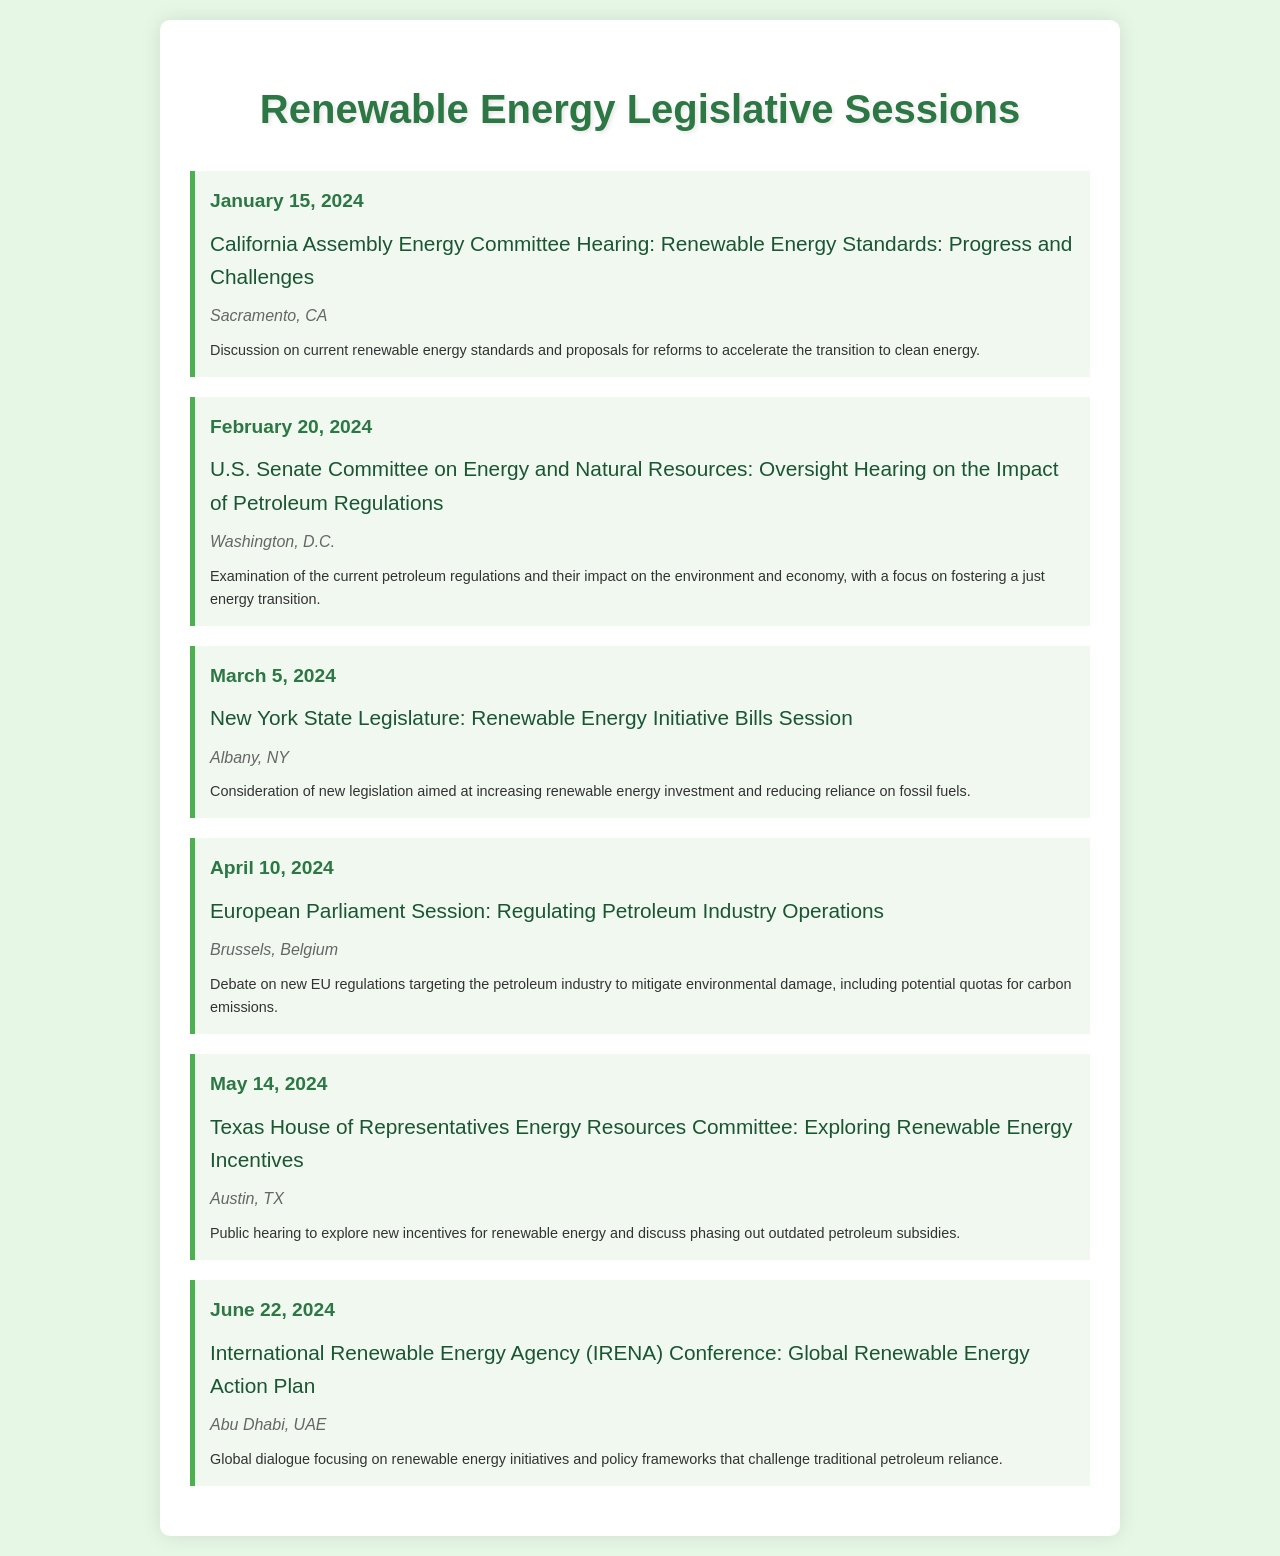What is the date of the California Assembly Energy Committee Hearing? The date of the California Assembly Energy Committee Hearing is specified as January 15, 2024.
Answer: January 15, 2024 What is the location of the Texas House of Representatives Energy Resources Committee hearing? The location of the Texas House of Representatives Energy Resources Committee hearing is listed as Austin, TX.
Answer: Austin, TX What is the title of the event scheduled for March 5, 2024? The title of the event scheduled for March 5, 2024, is stated as "New York State Legislature: Renewable Energy Initiative Bills Session."
Answer: Renewable Energy Initiative Bills Session Which event focuses on exploring renewable energy incentives? The event that focuses on exploring renewable energy incentives is the Texas House of Representatives Energy Resources Committee meeting on May 14, 2024.
Answer: Texas House of Representatives Energy Resources Committee How many legislative sessions are listed in total within the document? The total number of legislative sessions listed in the document is counted and amounts to six separate events.
Answer: Six What theme is addressed in the U.S. Senate Committee's February 20, 2024 hearing? The theme addressed in the U.S. Senate Committee's February 20, 2024 hearing is the impact of petroleum regulations.
Answer: Impact of petroleum regulations What is the main focus of the International Renewable Energy Agency Conference in June 2024? The main focus of the International Renewable Energy Agency Conference is a global dialogue on renewable energy initiatives.
Answer: Global dialogue on renewable energy initiatives 